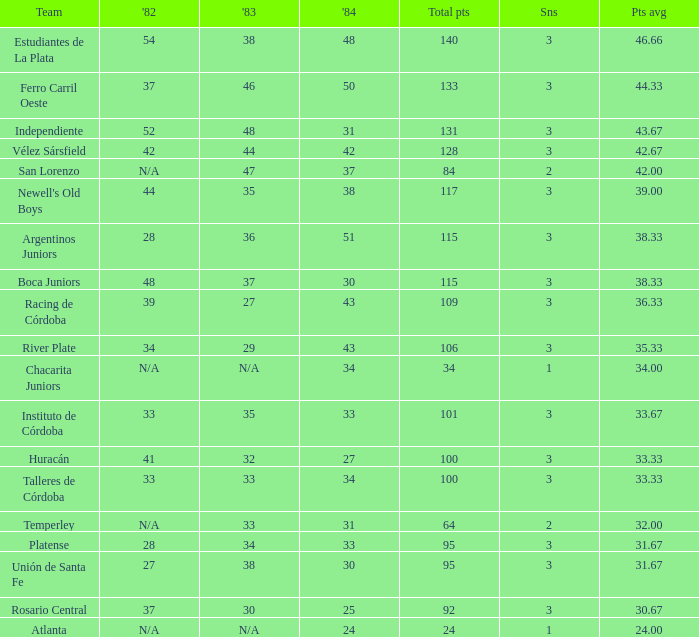What is the number of seasons for the team with a total fewer than 24? None. 